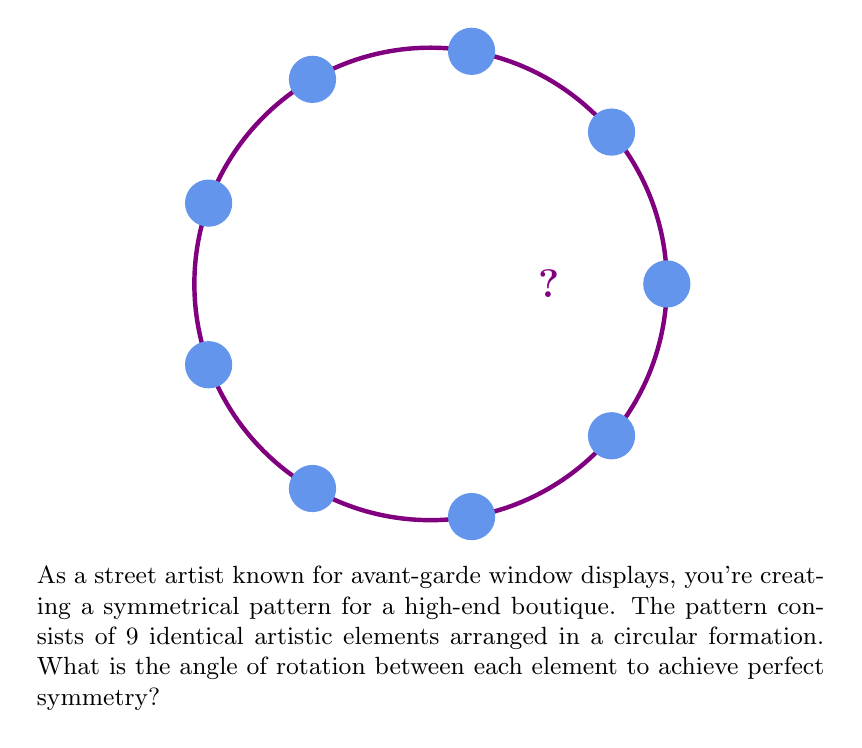Solve this math problem. To find the angle of rotation between each element, we need to consider that a full circle contains 360°. Since the pattern is symmetrical and contains 9 identical elements, we need to divide the full circle equally among these 9 elements.

Step 1: Set up the equation
$$\text{Angle of rotation} = \frac{\text{Total degrees in a circle}}{\text{Number of elements}}$$

Step 2: Substitute the known values
$$\text{Angle of rotation} = \frac{360°}{9}$$

Step 3: Perform the division
$$\text{Angle of rotation} = 40°$$

Therefore, each element should be rotated 40° from the previous one to create a perfectly symmetrical pattern in the circular window display.
Answer: $40°$ 